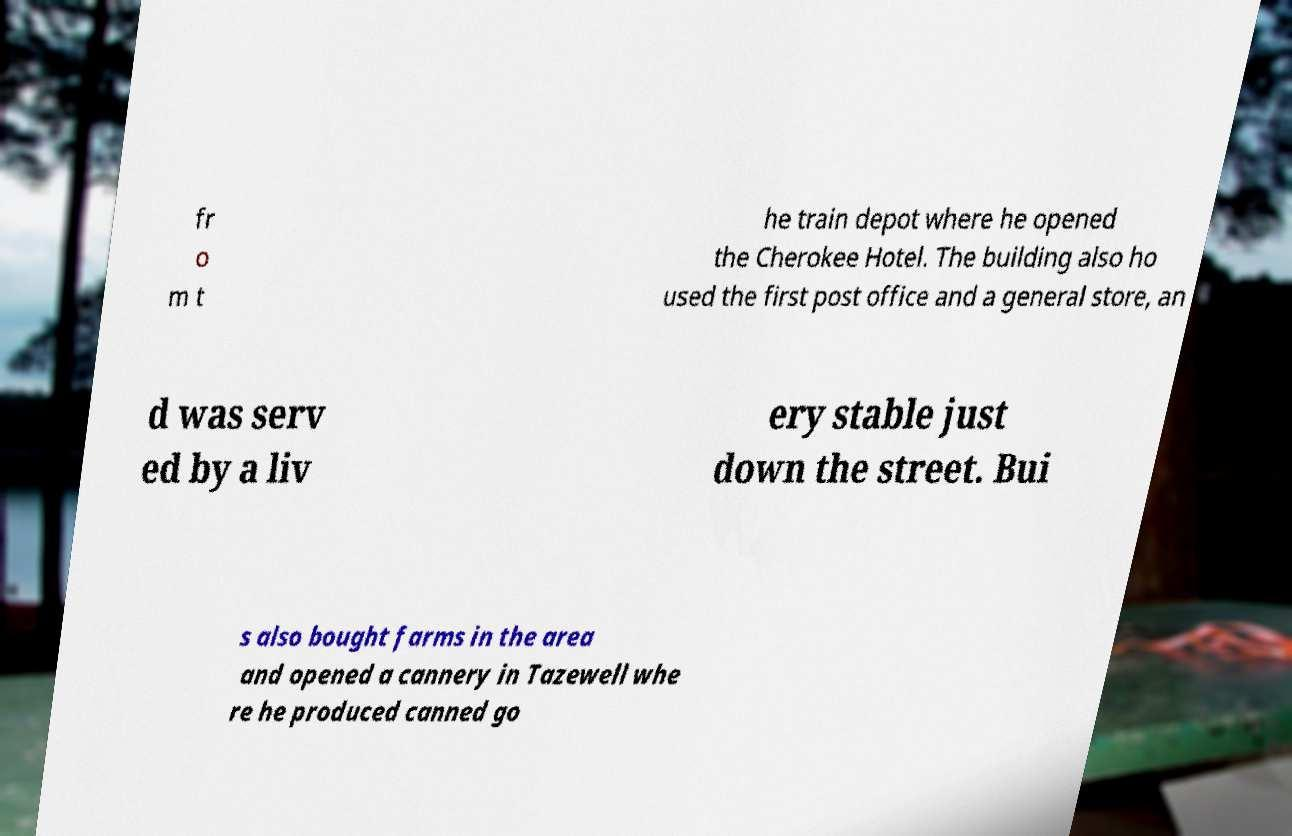I need the written content from this picture converted into text. Can you do that? fr o m t he train depot where he opened the Cherokee Hotel. The building also ho used the first post office and a general store, an d was serv ed by a liv ery stable just down the street. Bui s also bought farms in the area and opened a cannery in Tazewell whe re he produced canned go 